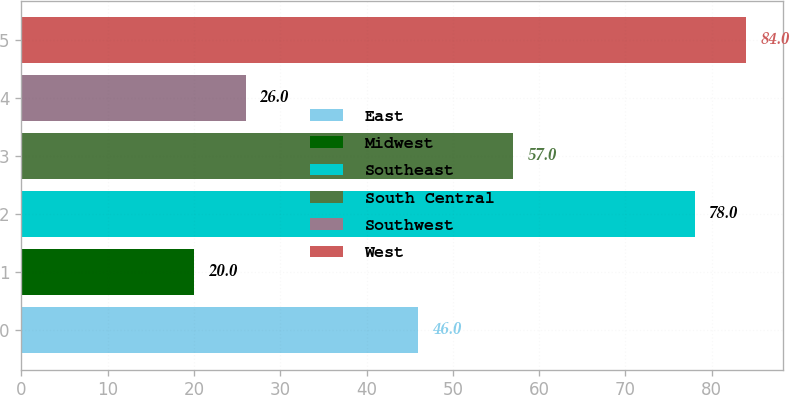Convert chart. <chart><loc_0><loc_0><loc_500><loc_500><bar_chart><fcel>East<fcel>Midwest<fcel>Southeast<fcel>South Central<fcel>Southwest<fcel>West<nl><fcel>46<fcel>20<fcel>78<fcel>57<fcel>26<fcel>84<nl></chart> 